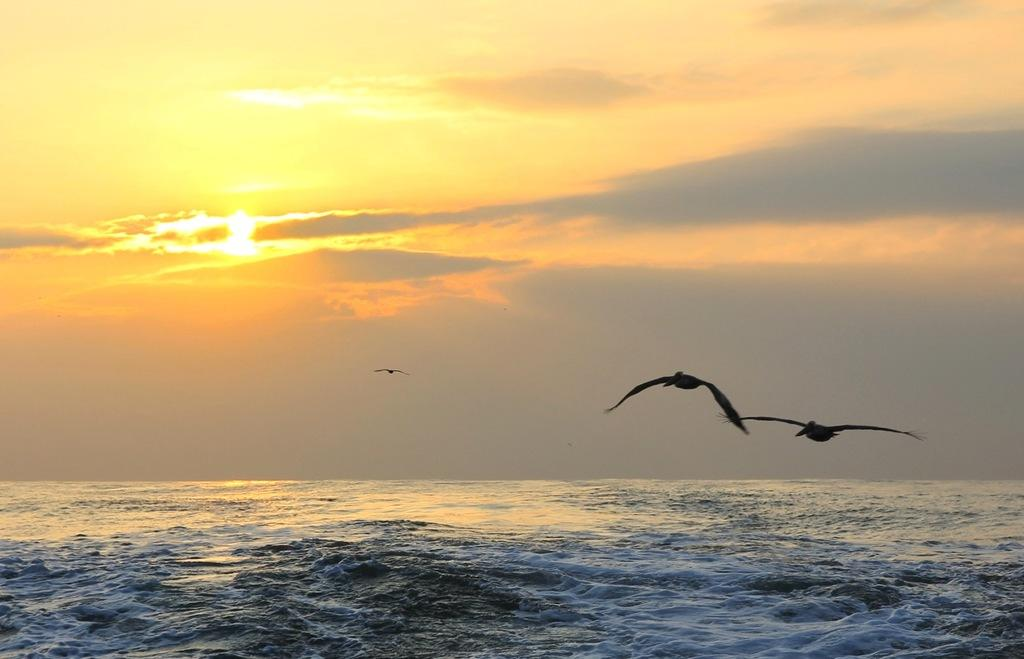What is visible in the image that is not solid? There is water visible in the image. What is the condition of the sky in the image? The sky appears to be cloudy in the image. Can the sun be seen in the image? Yes, the sun is observable in the image. What type of animals can be seen in the image? Birds are flying in the image. What type of jewel is being worn by the bird in the image? There are no birds wearing jewels in the image; the birds are simply flying. What event is being celebrated in the image? There is no event being celebrated in the image; it is a natural scene with water, sky, sun, and birds. 